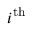<formula> <loc_0><loc_0><loc_500><loc_500>i ^ { t h }</formula> 